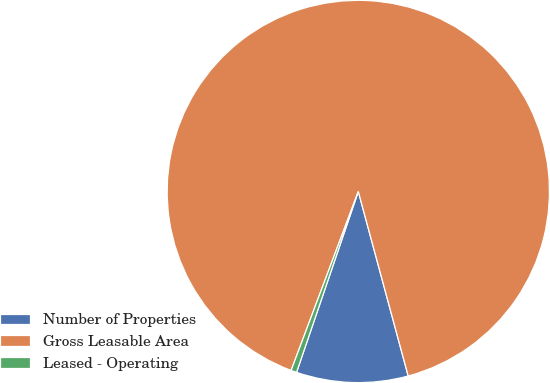<chart> <loc_0><loc_0><loc_500><loc_500><pie_chart><fcel>Number of Properties<fcel>Gross Leasable Area<fcel>Leased - Operating<nl><fcel>9.44%<fcel>90.08%<fcel>0.48%<nl></chart> 